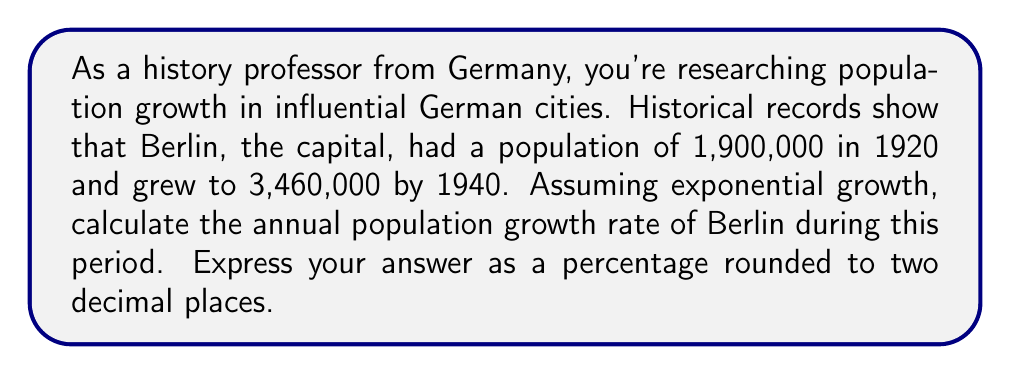Could you help me with this problem? To solve this problem, we'll use the exponential growth formula:

$$A = P(1 + r)^t$$

Where:
$A$ = Final amount (population in 1940)
$P$ = Initial amount (population in 1920)
$r$ = Annual growth rate (what we're solving for)
$t$ = Time period in years

Let's plug in the known values:

$$3,460,000 = 1,900,000(1 + r)^{20}$$

Now, let's solve for $r$:

1) Divide both sides by 1,900,000:
   $$\frac{3,460,000}{1,900,000} = (1 + r)^{20}$$

2) Simplify:
   $$1.821053 = (1 + r)^{20}$$

3) Take the 20th root of both sides:
   $$\sqrt[20]{1.821053} = 1 + r$$

4) Subtract 1 from both sides:
   $$\sqrt[20]{1.821053} - 1 = r$$

5) Calculate:
   $$r \approx 0.03062$$

6) Convert to a percentage:
   $$r \approx 3.062\%$$

Rounding to two decimal places, we get 3.06%.
Answer: 3.06% 